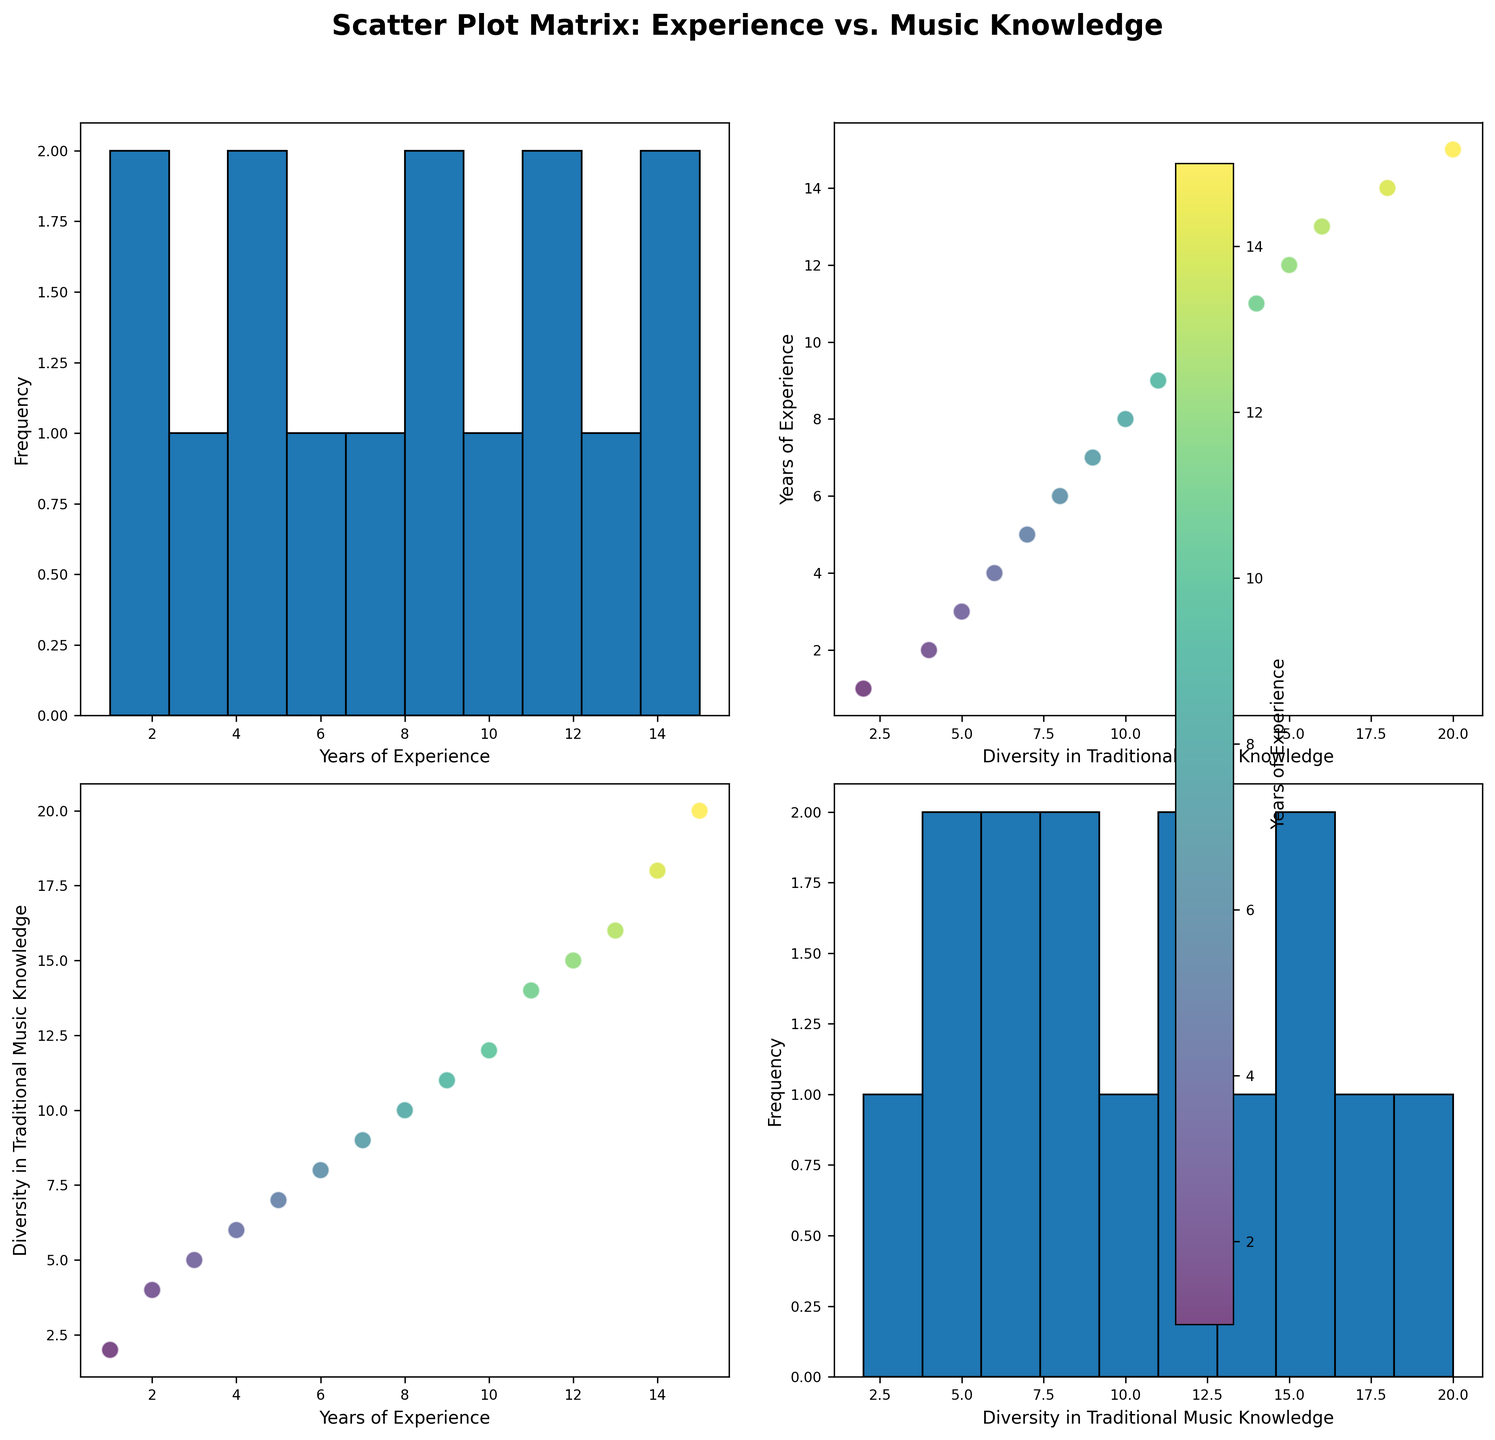what is the title of the plot? The plot's title is displayed prominently above the matrix, generally in a larger and bolder font. It states the overall theme or the main point of the plot.
Answer: Scatter Plot Matrix: Experience vs. Music Knowledge How many subplots does the figure contain? The figure is a 2x2 grid of subplots, combining scatter plots and histograms. You can count the number of individual plots in the grid.
Answer: Four What does the color of the scatter points represent? The color of the scatter points, which varies, is associated with a colorbar that labels it. This indicates that the color represents different levels of Years of Experience.
Answer: Years of Experience What's the frequency of data points with 10 years of experience in the histogram? The histogram subplot corresponding to 'Years of Experience' shows the frequency distribution of this variable. By observing the height of the bar, you can determine how many data points fall into the bin that includes 10 years.
Answer: One What's the range of the x-axis for the scatter plot where 'Years of Experience' is on the y-axis and 'Diversity in Traditional Music Knowledge' on the x-axis? For the scatter plot with Years of Experience on the y-axis and Diversity in Traditional Music Knowledge on the x-axis, the x-axis range is determined by the minimum and maximum values of Diversity in Traditional Music Knowledge in the data.
Answer: 2 to 20 Which region has the member with the highest Diversity in Traditional Music Knowledge? By locating the highest point on the scatter plot for Diversity in Traditional Music Knowledge and referring to, if provided, the region of data points in the dataset can help us determine the region. The data point with Diversity in Traditional Music Knowledge of 20 belongs to Africa. This can be matched with details such as colors or coordinates corresponding to the highest point in the plot.
Answer: Africa How does the Diversity in Traditional Music Knowledge compare for the two data points with 14 and 15 years of experience? Locate the data points with 14 and 15 years of experience on the scatter plots. Observe their corresponding Diversity in Traditional Music Knowledge values and compare them. The point with 14 years of experience has Diversity in Traditional Music Knowledge of 18, and the point with 15 years has 20.
Answer: 18 (for 14 years of experience), 20 (for 15 years of experience) What is the correlation pattern observed between 'Years of Experience' and 'Diversity in Traditional Music Knowledge'? The scatter plot showing Years of Experience on one axis and Diversity in Traditional Music Knowledge on the other illustrates a pattern. If the points form an upward trend, it suggests a positive correlation.
Answer: Positive correlation What is the median value of 'Years of Experience' shown in the histogram? To find the median value in the histogram for 'Years of Experience', locate the middle value of the dataset. With 15 values, organizing them and identifying the center one (8th value) gives 9.
Answer: 9 If you pick a point randomly appearing in the scatter plots, what is it more likely to represent: an individual from North America or Africa? Given the scatter plot, observing the distribution and identifying clusters or general quantity of points that belong to each region can help determine the likeliness of the randomly picked point. With three points each from North America and Africa, the likelihood is even between the two.
Answer: Even (equal likelihood) 